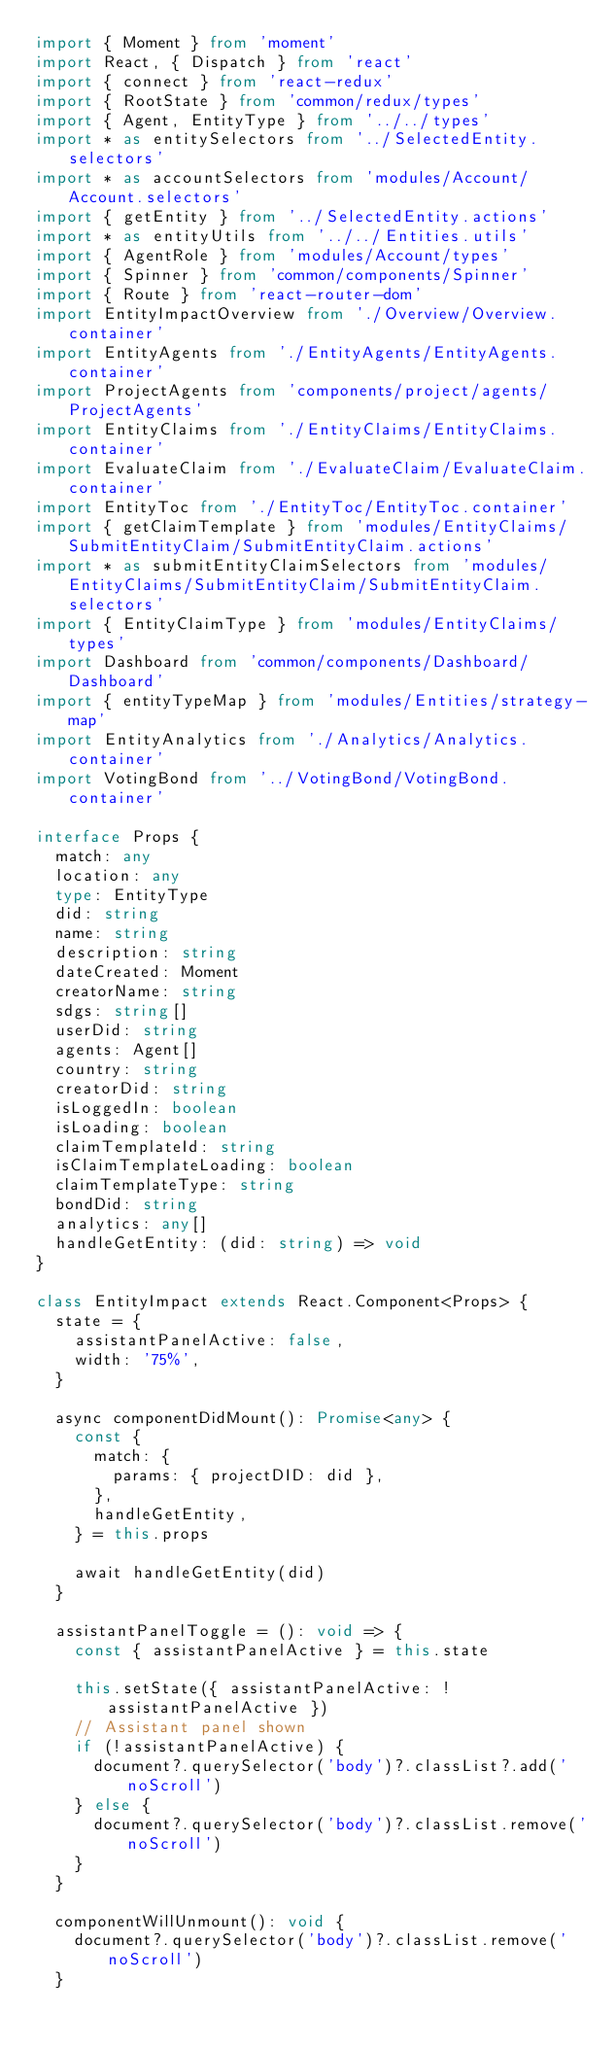Convert code to text. <code><loc_0><loc_0><loc_500><loc_500><_TypeScript_>import { Moment } from 'moment'
import React, { Dispatch } from 'react'
import { connect } from 'react-redux'
import { RootState } from 'common/redux/types'
import { Agent, EntityType } from '../../types'
import * as entitySelectors from '../SelectedEntity.selectors'
import * as accountSelectors from 'modules/Account/Account.selectors'
import { getEntity } from '../SelectedEntity.actions'
import * as entityUtils from '../../Entities.utils'
import { AgentRole } from 'modules/Account/types'
import { Spinner } from 'common/components/Spinner'
import { Route } from 'react-router-dom'
import EntityImpactOverview from './Overview/Overview.container'
import EntityAgents from './EntityAgents/EntityAgents.container'
import ProjectAgents from 'components/project/agents/ProjectAgents'
import EntityClaims from './EntityClaims/EntityClaims.container'
import EvaluateClaim from './EvaluateClaim/EvaluateClaim.container'
import EntityToc from './EntityToc/EntityToc.container'
import { getClaimTemplate } from 'modules/EntityClaims/SubmitEntityClaim/SubmitEntityClaim.actions'
import * as submitEntityClaimSelectors from 'modules/EntityClaims/SubmitEntityClaim/SubmitEntityClaim.selectors'
import { EntityClaimType } from 'modules/EntityClaims/types'
import Dashboard from 'common/components/Dashboard/Dashboard'
import { entityTypeMap } from 'modules/Entities/strategy-map'
import EntityAnalytics from './Analytics/Analytics.container'
import VotingBond from '../VotingBond/VotingBond.container'

interface Props {
  match: any
  location: any
  type: EntityType
  did: string
  name: string
  description: string
  dateCreated: Moment
  creatorName: string
  sdgs: string[]
  userDid: string
  agents: Agent[]
  country: string
  creatorDid: string
  isLoggedIn: boolean
  isLoading: boolean
  claimTemplateId: string
  isClaimTemplateLoading: boolean
  claimTemplateType: string
  bondDid: string
  analytics: any[]
  handleGetEntity: (did: string) => void
}

class EntityImpact extends React.Component<Props> {
  state = {
    assistantPanelActive: false,
    width: '75%',
  }

  async componentDidMount(): Promise<any> {
    const {
      match: {
        params: { projectDID: did },
      },
      handleGetEntity,
    } = this.props

    await handleGetEntity(did)
  }

  assistantPanelToggle = (): void => {
    const { assistantPanelActive } = this.state

    this.setState({ assistantPanelActive: !assistantPanelActive })
    // Assistant panel shown
    if (!assistantPanelActive) {
      document?.querySelector('body')?.classList?.add('noScroll')
    } else {
      document?.querySelector('body')?.classList.remove('noScroll')
    }
  }

  componentWillUnmount(): void {
    document?.querySelector('body')?.classList.remove('noScroll')
  }
</code> 